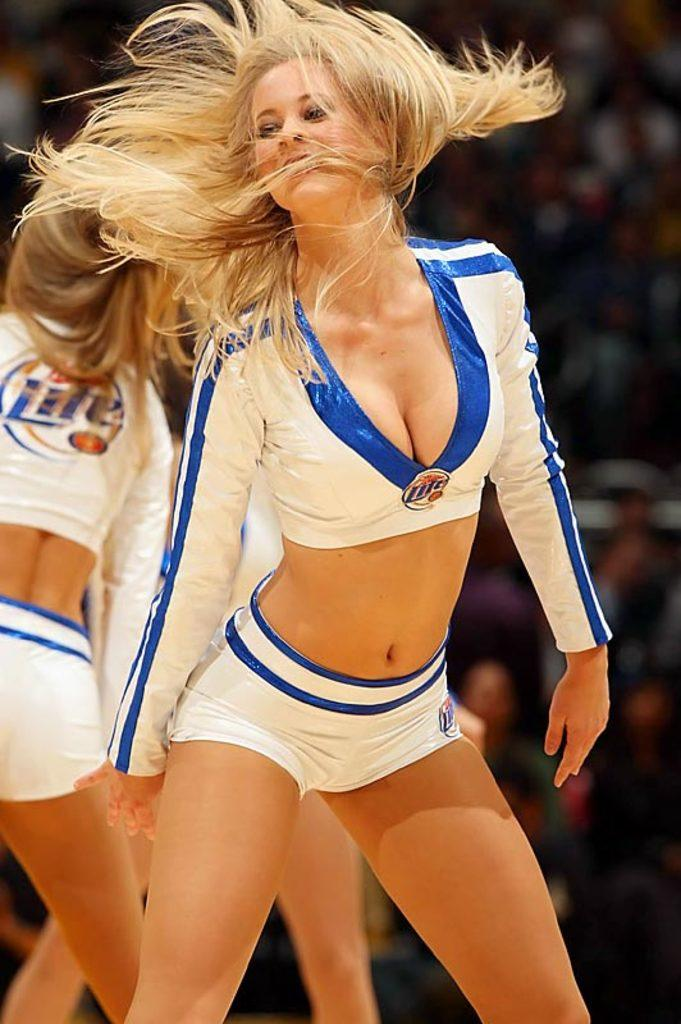Provide a one-sentence caption for the provided image. Cheerleaders wearing Miller Lite on their uniform perform at a game. 